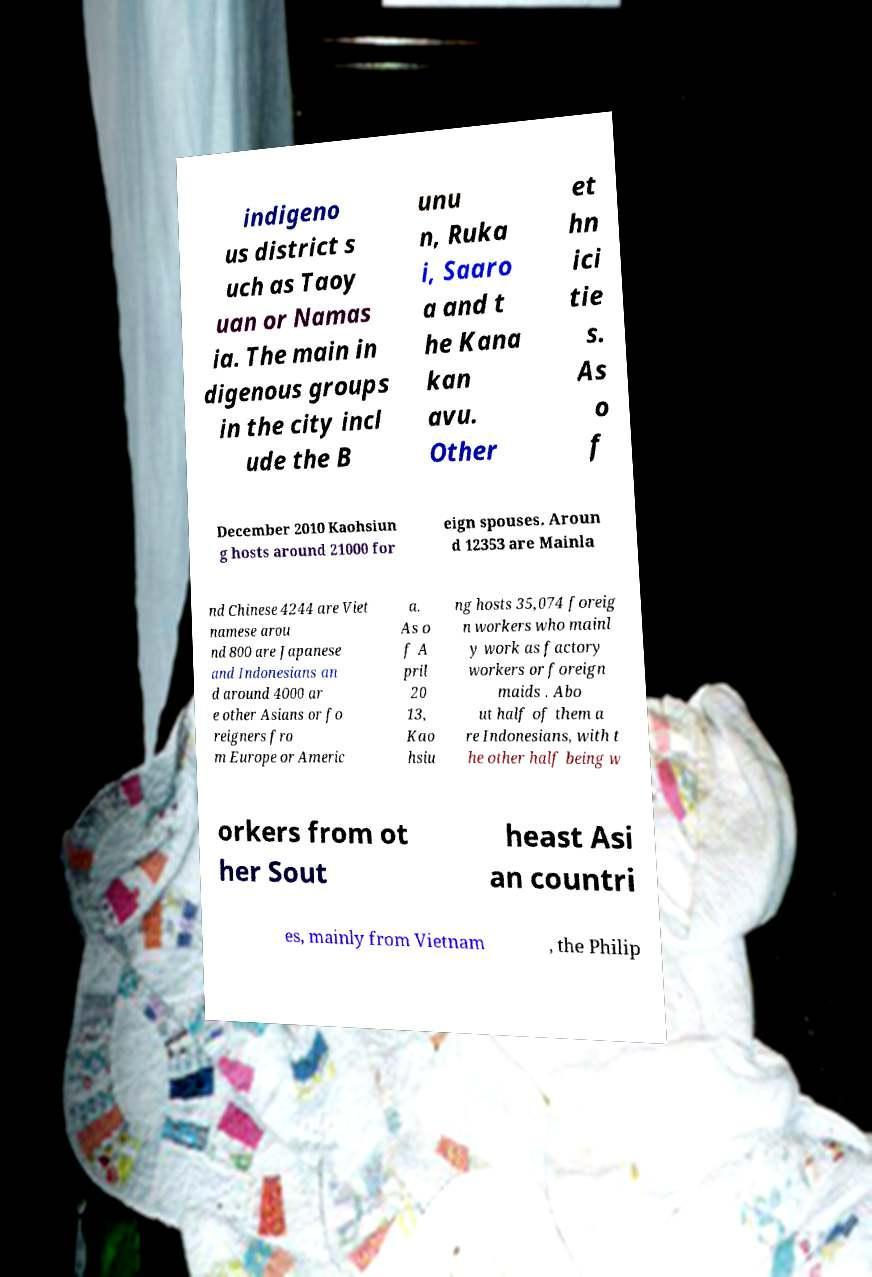Could you extract and type out the text from this image? indigeno us district s uch as Taoy uan or Namas ia. The main in digenous groups in the city incl ude the B unu n, Ruka i, Saaro a and t he Kana kan avu. Other et hn ici tie s. As o f December 2010 Kaohsiun g hosts around 21000 for eign spouses. Aroun d 12353 are Mainla nd Chinese 4244 are Viet namese arou nd 800 are Japanese and Indonesians an d around 4000 ar e other Asians or fo reigners fro m Europe or Americ a. As o f A pril 20 13, Kao hsiu ng hosts 35,074 foreig n workers who mainl y work as factory workers or foreign maids . Abo ut half of them a re Indonesians, with t he other half being w orkers from ot her Sout heast Asi an countri es, mainly from Vietnam , the Philip 